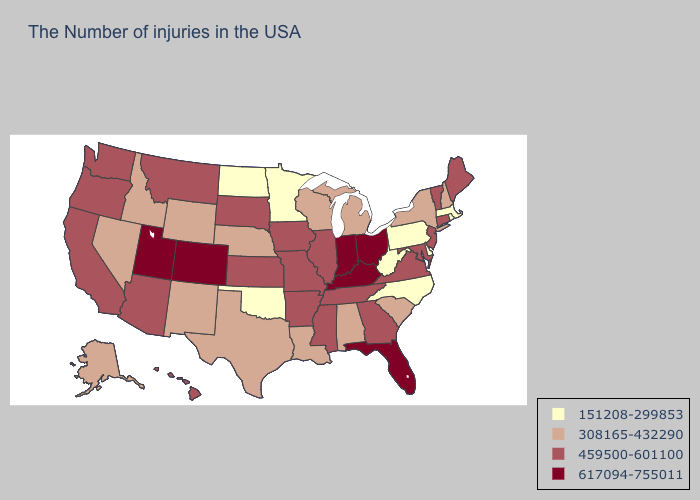Among the states that border Nebraska , does Colorado have the highest value?
Be succinct. Yes. Which states have the highest value in the USA?
Short answer required. Ohio, Florida, Kentucky, Indiana, Colorado, Utah. Which states hav the highest value in the West?
Give a very brief answer. Colorado, Utah. Does Oklahoma have the highest value in the South?
Be succinct. No. Is the legend a continuous bar?
Short answer required. No. Name the states that have a value in the range 151208-299853?
Answer briefly. Massachusetts, Rhode Island, Delaware, Pennsylvania, North Carolina, West Virginia, Minnesota, Oklahoma, North Dakota. Among the states that border Wisconsin , does Iowa have the highest value?
Quick response, please. Yes. Name the states that have a value in the range 308165-432290?
Write a very short answer. New Hampshire, New York, South Carolina, Michigan, Alabama, Wisconsin, Louisiana, Nebraska, Texas, Wyoming, New Mexico, Idaho, Nevada, Alaska. Does the first symbol in the legend represent the smallest category?
Short answer required. Yes. What is the highest value in the USA?
Concise answer only. 617094-755011. Name the states that have a value in the range 617094-755011?
Answer briefly. Ohio, Florida, Kentucky, Indiana, Colorado, Utah. What is the highest value in the USA?
Write a very short answer. 617094-755011. Does New Mexico have the lowest value in the USA?
Answer briefly. No. Does Florida have the highest value in the South?
Give a very brief answer. Yes. What is the value of Kansas?
Concise answer only. 459500-601100. 